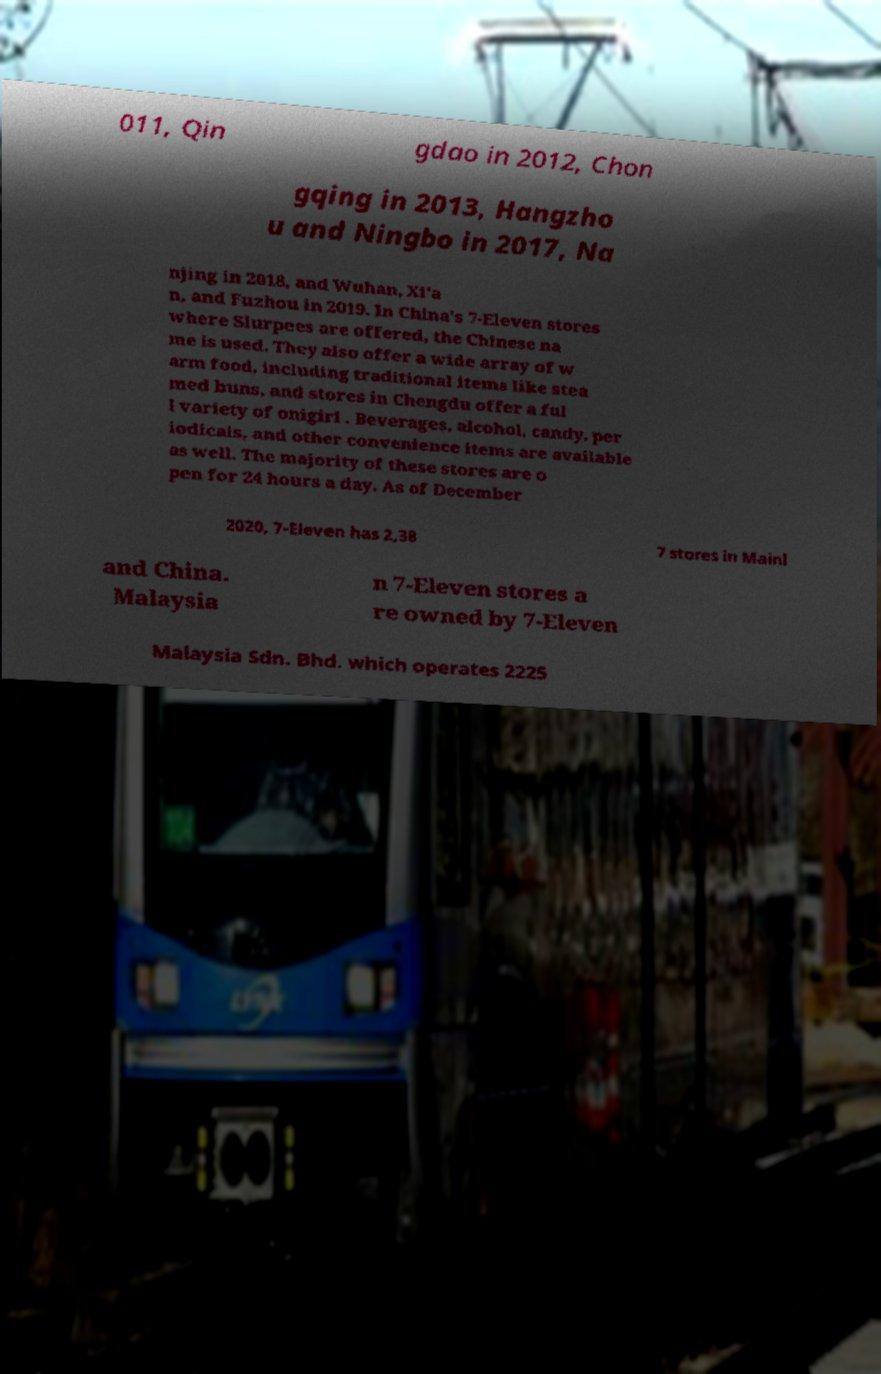Can you read and provide the text displayed in the image?This photo seems to have some interesting text. Can you extract and type it out for me? 011, Qin gdao in 2012, Chon gqing in 2013, Hangzho u and Ningbo in 2017, Na njing in 2018, and Wuhan, Xi'a n, and Fuzhou in 2019. In China's 7-Eleven stores where Slurpees are offered, the Chinese na me is used. They also offer a wide array of w arm food, including traditional items like stea med buns, and stores in Chengdu offer a ful l variety of onigiri . Beverages, alcohol, candy, per iodicals, and other convenience items are available as well. The majority of these stores are o pen for 24 hours a day. As of December 2020, 7-Eleven has 2,38 7 stores in Mainl and China. Malaysia n 7-Eleven stores a re owned by 7-Eleven Malaysia Sdn. Bhd. which operates 2225 